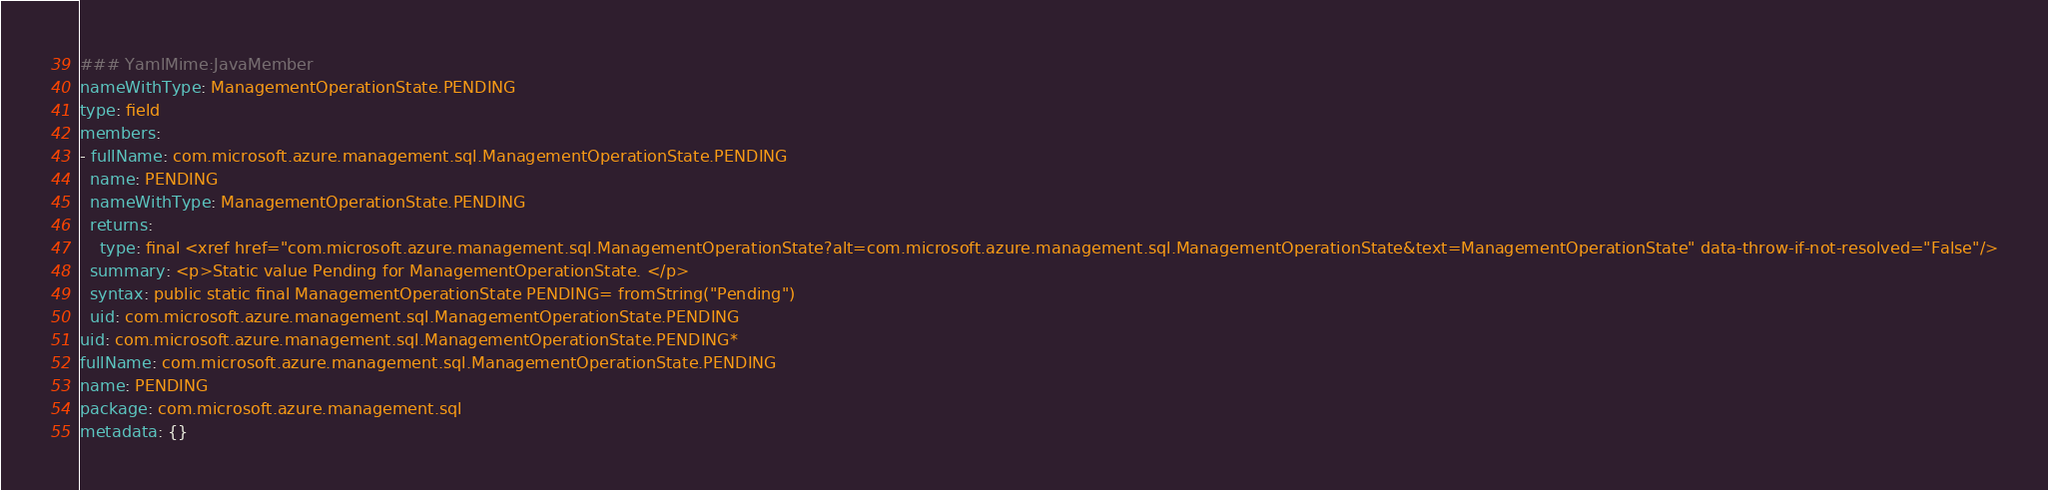<code> <loc_0><loc_0><loc_500><loc_500><_YAML_>### YamlMime:JavaMember
nameWithType: ManagementOperationState.PENDING
type: field
members:
- fullName: com.microsoft.azure.management.sql.ManagementOperationState.PENDING
  name: PENDING
  nameWithType: ManagementOperationState.PENDING
  returns:
    type: final <xref href="com.microsoft.azure.management.sql.ManagementOperationState?alt=com.microsoft.azure.management.sql.ManagementOperationState&text=ManagementOperationState" data-throw-if-not-resolved="False"/>
  summary: <p>Static value Pending for ManagementOperationState. </p>
  syntax: public static final ManagementOperationState PENDING= fromString("Pending")
  uid: com.microsoft.azure.management.sql.ManagementOperationState.PENDING
uid: com.microsoft.azure.management.sql.ManagementOperationState.PENDING*
fullName: com.microsoft.azure.management.sql.ManagementOperationState.PENDING
name: PENDING
package: com.microsoft.azure.management.sql
metadata: {}
</code> 